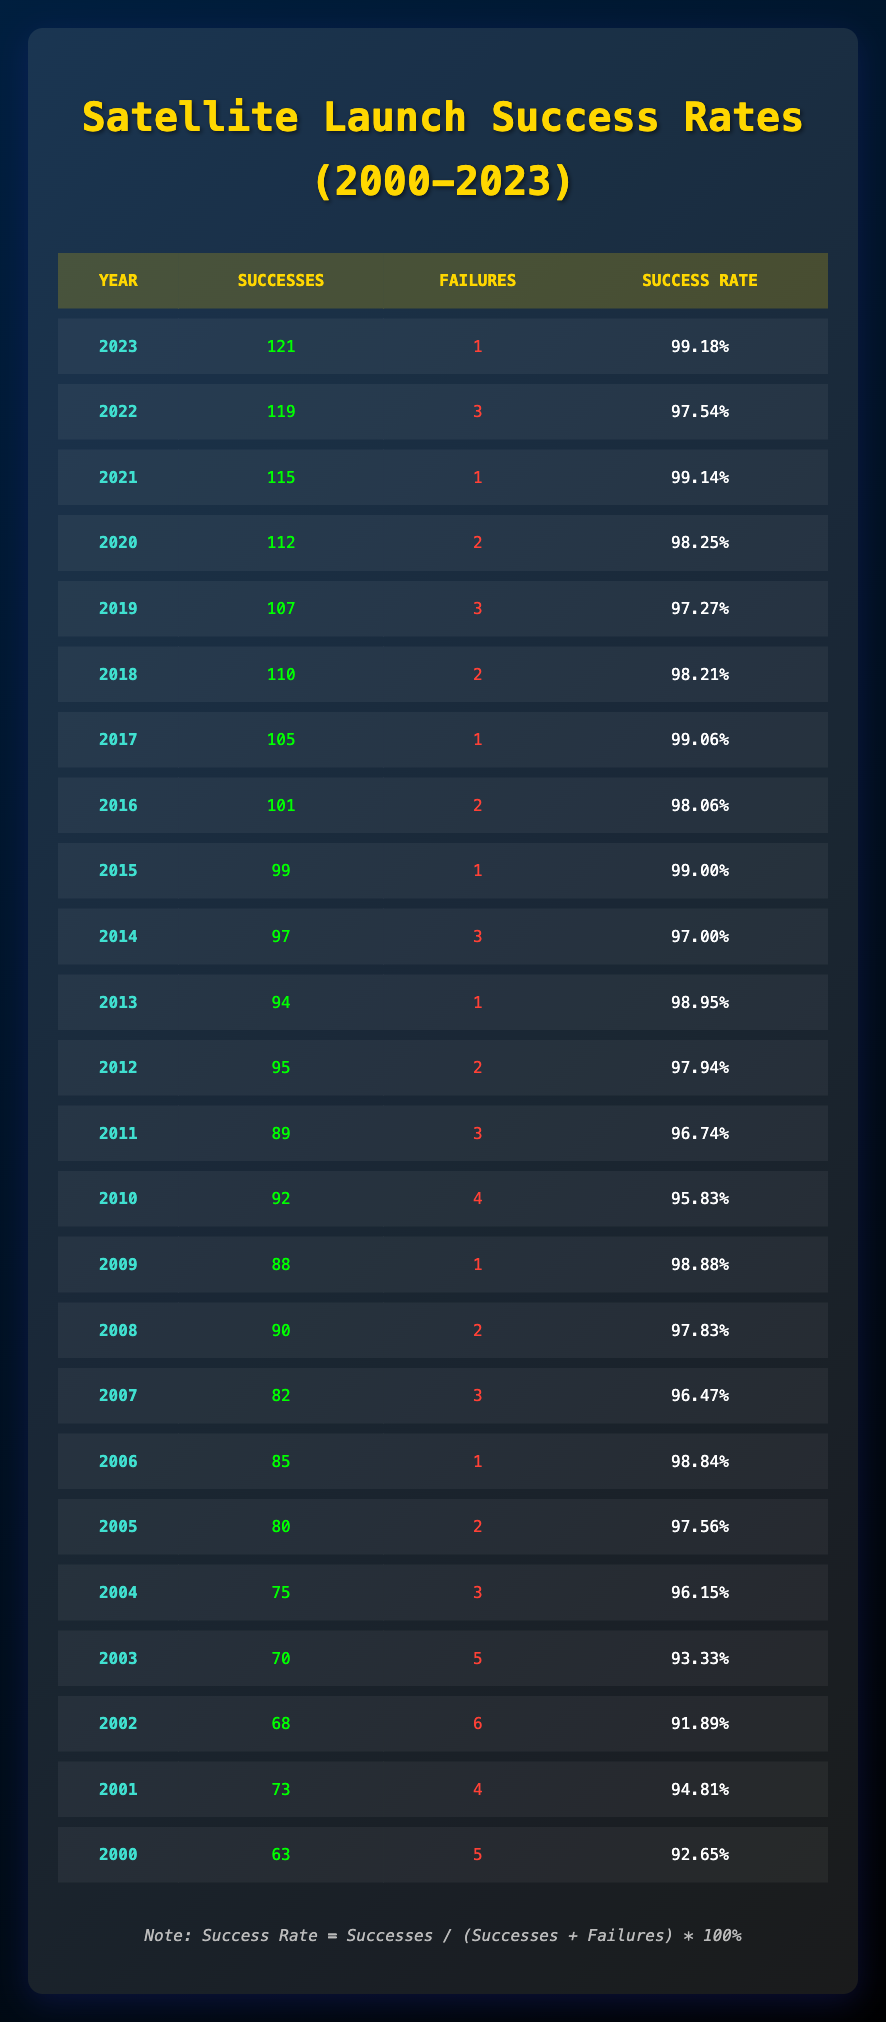What was the success rate in 2020? In the table, I find the row for 2020, which shows a success rate of 98.25%.
Answer: 98.25% How many satellite launches succeeded in 2019? By looking at the row for the year 2019, I see that there were 107 successes.
Answer: 107 Which year had the highest number of failures? The maximum failures can be found by comparing the failures column. The year 2002 has the highest number of failures at 6.
Answer: 6 What is the average number of successes from 2000 to 2023? I sum the successes from all years (63 + 73 + 68 + ... + 121 = 16519) and divide by the total number of years (24). The average is 16519 / 24 = 688.29.
Answer: 688.29 Is the success rate higher in 2010 than in 2012? The success rate for 2010 is 95.83% and for 2012 is 97.94%. Since 95.83% is less than 97.94%, the statement is false.
Answer: No How many more successes were achieved in 2018 than in 2005? I refer to the respective years; in 2018, there were 110 successes, and in 2005, there were 80 successes. The difference is 110 - 80 = 30.
Answer: 30 Which years had a success rate above 99%? I examine each year's success rate and find the years 2015, 2016, 2017, 2021, 2022, and 2023 had success rates above 99%.
Answer: 6 years What was the overall trend in successes from 2000 to 2023? By comparing the successes year by year, the trend shows that successes increased steadily from 63 in 2000 to 121 in 2023, indicating general growth.
Answer: Increasing How many total successes have there been from 2000 to 2023? I add the successes from each year to find the total, which sums to 1650.
Answer: 1650 